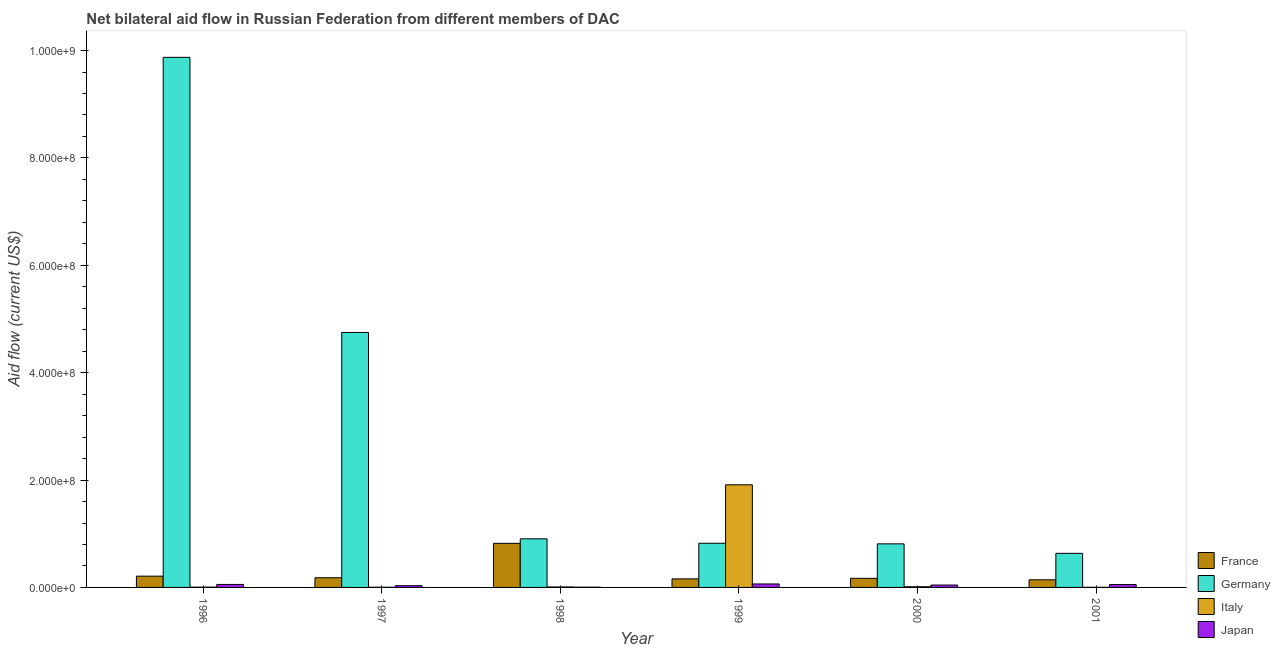Are the number of bars per tick equal to the number of legend labels?
Give a very brief answer. Yes. How many bars are there on the 3rd tick from the left?
Keep it short and to the point. 4. How many bars are there on the 3rd tick from the right?
Your answer should be very brief. 4. What is the amount of aid given by germany in 2000?
Offer a very short reply. 8.12e+07. Across all years, what is the maximum amount of aid given by italy?
Make the answer very short. 1.91e+08. Across all years, what is the minimum amount of aid given by italy?
Keep it short and to the point. 2.40e+05. In which year was the amount of aid given by france minimum?
Ensure brevity in your answer.  2001. What is the total amount of aid given by japan in the graph?
Give a very brief answer. 2.56e+07. What is the difference between the amount of aid given by france in 1997 and that in 1998?
Give a very brief answer. -6.41e+07. What is the difference between the amount of aid given by france in 2001 and the amount of aid given by japan in 1999?
Offer a terse response. -1.71e+06. What is the average amount of aid given by italy per year?
Offer a very short reply. 3.24e+07. What is the ratio of the amount of aid given by italy in 1998 to that in 2000?
Keep it short and to the point. 0.69. Is the amount of aid given by japan in 1996 less than that in 2001?
Offer a very short reply. No. What is the difference between the highest and the second highest amount of aid given by italy?
Your response must be concise. 1.90e+08. What is the difference between the highest and the lowest amount of aid given by france?
Offer a very short reply. 6.79e+07. What does the 1st bar from the left in 2000 represents?
Make the answer very short. France. What does the 3rd bar from the right in 2000 represents?
Your answer should be compact. Germany. Is it the case that in every year, the sum of the amount of aid given by france and amount of aid given by germany is greater than the amount of aid given by italy?
Provide a succinct answer. No. Does the graph contain any zero values?
Your response must be concise. No. Does the graph contain grids?
Keep it short and to the point. No. How many legend labels are there?
Your answer should be very brief. 4. How are the legend labels stacked?
Provide a short and direct response. Vertical. What is the title of the graph?
Make the answer very short. Net bilateral aid flow in Russian Federation from different members of DAC. What is the label or title of the X-axis?
Provide a short and direct response. Year. What is the label or title of the Y-axis?
Keep it short and to the point. Aid flow (current US$). What is the Aid flow (current US$) of France in 1996?
Your response must be concise. 2.10e+07. What is the Aid flow (current US$) in Germany in 1996?
Offer a very short reply. 9.87e+08. What is the Aid flow (current US$) of Italy in 1996?
Your answer should be compact. 5.10e+05. What is the Aid flow (current US$) in Japan in 1996?
Provide a succinct answer. 5.56e+06. What is the Aid flow (current US$) of France in 1997?
Give a very brief answer. 1.80e+07. What is the Aid flow (current US$) of Germany in 1997?
Provide a short and direct response. 4.75e+08. What is the Aid flow (current US$) in Italy in 1997?
Your answer should be compact. 3.00e+05. What is the Aid flow (current US$) in Japan in 1997?
Offer a very short reply. 3.26e+06. What is the Aid flow (current US$) in France in 1998?
Your answer should be very brief. 8.21e+07. What is the Aid flow (current US$) in Germany in 1998?
Offer a very short reply. 9.05e+07. What is the Aid flow (current US$) in Italy in 1998?
Keep it short and to the point. 8.80e+05. What is the Aid flow (current US$) in France in 1999?
Give a very brief answer. 1.59e+07. What is the Aid flow (current US$) in Germany in 1999?
Your response must be concise. 8.23e+07. What is the Aid flow (current US$) in Italy in 1999?
Your answer should be compact. 1.91e+08. What is the Aid flow (current US$) of Japan in 1999?
Give a very brief answer. 6.47e+06. What is the Aid flow (current US$) of France in 2000?
Your answer should be compact. 1.70e+07. What is the Aid flow (current US$) in Germany in 2000?
Ensure brevity in your answer.  8.12e+07. What is the Aid flow (current US$) in Italy in 2000?
Offer a very short reply. 1.28e+06. What is the Aid flow (current US$) of Japan in 2000?
Make the answer very short. 4.46e+06. What is the Aid flow (current US$) in France in 2001?
Ensure brevity in your answer.  1.42e+07. What is the Aid flow (current US$) of Germany in 2001?
Give a very brief answer. 6.35e+07. What is the Aid flow (current US$) in Japan in 2001?
Your answer should be compact. 5.31e+06. Across all years, what is the maximum Aid flow (current US$) of France?
Make the answer very short. 8.21e+07. Across all years, what is the maximum Aid flow (current US$) in Germany?
Make the answer very short. 9.87e+08. Across all years, what is the maximum Aid flow (current US$) in Italy?
Provide a succinct answer. 1.91e+08. Across all years, what is the maximum Aid flow (current US$) of Japan?
Your answer should be compact. 6.47e+06. Across all years, what is the minimum Aid flow (current US$) of France?
Provide a succinct answer. 1.42e+07. Across all years, what is the minimum Aid flow (current US$) in Germany?
Your answer should be very brief. 6.35e+07. What is the total Aid flow (current US$) in France in the graph?
Ensure brevity in your answer.  1.68e+08. What is the total Aid flow (current US$) in Germany in the graph?
Your response must be concise. 1.78e+09. What is the total Aid flow (current US$) in Italy in the graph?
Offer a terse response. 1.94e+08. What is the total Aid flow (current US$) in Japan in the graph?
Your answer should be very brief. 2.56e+07. What is the difference between the Aid flow (current US$) of France in 1996 and that in 1997?
Ensure brevity in your answer.  2.98e+06. What is the difference between the Aid flow (current US$) of Germany in 1996 and that in 1997?
Offer a very short reply. 5.12e+08. What is the difference between the Aid flow (current US$) in Italy in 1996 and that in 1997?
Your answer should be very brief. 2.10e+05. What is the difference between the Aid flow (current US$) in Japan in 1996 and that in 1997?
Offer a very short reply. 2.30e+06. What is the difference between the Aid flow (current US$) in France in 1996 and that in 1998?
Your answer should be compact. -6.11e+07. What is the difference between the Aid flow (current US$) of Germany in 1996 and that in 1998?
Your answer should be very brief. 8.97e+08. What is the difference between the Aid flow (current US$) in Italy in 1996 and that in 1998?
Give a very brief answer. -3.70e+05. What is the difference between the Aid flow (current US$) of Japan in 1996 and that in 1998?
Your answer should be very brief. 5.06e+06. What is the difference between the Aid flow (current US$) of France in 1996 and that in 1999?
Your response must be concise. 5.09e+06. What is the difference between the Aid flow (current US$) in Germany in 1996 and that in 1999?
Ensure brevity in your answer.  9.05e+08. What is the difference between the Aid flow (current US$) of Italy in 1996 and that in 1999?
Provide a succinct answer. -1.91e+08. What is the difference between the Aid flow (current US$) of Japan in 1996 and that in 1999?
Make the answer very short. -9.10e+05. What is the difference between the Aid flow (current US$) in France in 1996 and that in 2000?
Make the answer very short. 4.05e+06. What is the difference between the Aid flow (current US$) in Germany in 1996 and that in 2000?
Make the answer very short. 9.06e+08. What is the difference between the Aid flow (current US$) in Italy in 1996 and that in 2000?
Offer a very short reply. -7.70e+05. What is the difference between the Aid flow (current US$) of Japan in 1996 and that in 2000?
Provide a succinct answer. 1.10e+06. What is the difference between the Aid flow (current US$) in France in 1996 and that in 2001?
Give a very brief answer. 6.80e+06. What is the difference between the Aid flow (current US$) in Germany in 1996 and that in 2001?
Your answer should be compact. 9.24e+08. What is the difference between the Aid flow (current US$) of France in 1997 and that in 1998?
Give a very brief answer. -6.41e+07. What is the difference between the Aid flow (current US$) in Germany in 1997 and that in 1998?
Ensure brevity in your answer.  3.84e+08. What is the difference between the Aid flow (current US$) of Italy in 1997 and that in 1998?
Your answer should be compact. -5.80e+05. What is the difference between the Aid flow (current US$) of Japan in 1997 and that in 1998?
Offer a very short reply. 2.76e+06. What is the difference between the Aid flow (current US$) in France in 1997 and that in 1999?
Provide a short and direct response. 2.11e+06. What is the difference between the Aid flow (current US$) of Germany in 1997 and that in 1999?
Provide a short and direct response. 3.93e+08. What is the difference between the Aid flow (current US$) of Italy in 1997 and that in 1999?
Keep it short and to the point. -1.91e+08. What is the difference between the Aid flow (current US$) in Japan in 1997 and that in 1999?
Keep it short and to the point. -3.21e+06. What is the difference between the Aid flow (current US$) of France in 1997 and that in 2000?
Provide a short and direct response. 1.07e+06. What is the difference between the Aid flow (current US$) in Germany in 1997 and that in 2000?
Your answer should be very brief. 3.94e+08. What is the difference between the Aid flow (current US$) of Italy in 1997 and that in 2000?
Your response must be concise. -9.80e+05. What is the difference between the Aid flow (current US$) in Japan in 1997 and that in 2000?
Offer a very short reply. -1.20e+06. What is the difference between the Aid flow (current US$) of France in 1997 and that in 2001?
Provide a succinct answer. 3.82e+06. What is the difference between the Aid flow (current US$) of Germany in 1997 and that in 2001?
Your response must be concise. 4.11e+08. What is the difference between the Aid flow (current US$) in Japan in 1997 and that in 2001?
Provide a short and direct response. -2.05e+06. What is the difference between the Aid flow (current US$) of France in 1998 and that in 1999?
Offer a very short reply. 6.62e+07. What is the difference between the Aid flow (current US$) of Germany in 1998 and that in 1999?
Ensure brevity in your answer.  8.28e+06. What is the difference between the Aid flow (current US$) in Italy in 1998 and that in 1999?
Ensure brevity in your answer.  -1.90e+08. What is the difference between the Aid flow (current US$) of Japan in 1998 and that in 1999?
Offer a terse response. -5.97e+06. What is the difference between the Aid flow (current US$) of France in 1998 and that in 2000?
Offer a very short reply. 6.52e+07. What is the difference between the Aid flow (current US$) in Germany in 1998 and that in 2000?
Your answer should be compact. 9.39e+06. What is the difference between the Aid flow (current US$) in Italy in 1998 and that in 2000?
Keep it short and to the point. -4.00e+05. What is the difference between the Aid flow (current US$) in Japan in 1998 and that in 2000?
Your answer should be very brief. -3.96e+06. What is the difference between the Aid flow (current US$) in France in 1998 and that in 2001?
Keep it short and to the point. 6.79e+07. What is the difference between the Aid flow (current US$) in Germany in 1998 and that in 2001?
Offer a terse response. 2.70e+07. What is the difference between the Aid flow (current US$) in Italy in 1998 and that in 2001?
Give a very brief answer. 6.40e+05. What is the difference between the Aid flow (current US$) in Japan in 1998 and that in 2001?
Keep it short and to the point. -4.81e+06. What is the difference between the Aid flow (current US$) of France in 1999 and that in 2000?
Keep it short and to the point. -1.04e+06. What is the difference between the Aid flow (current US$) of Germany in 1999 and that in 2000?
Keep it short and to the point. 1.11e+06. What is the difference between the Aid flow (current US$) of Italy in 1999 and that in 2000?
Offer a very short reply. 1.90e+08. What is the difference between the Aid flow (current US$) of Japan in 1999 and that in 2000?
Provide a succinct answer. 2.01e+06. What is the difference between the Aid flow (current US$) of France in 1999 and that in 2001?
Offer a terse response. 1.71e+06. What is the difference between the Aid flow (current US$) in Germany in 1999 and that in 2001?
Give a very brief answer. 1.88e+07. What is the difference between the Aid flow (current US$) of Italy in 1999 and that in 2001?
Provide a succinct answer. 1.91e+08. What is the difference between the Aid flow (current US$) in Japan in 1999 and that in 2001?
Provide a short and direct response. 1.16e+06. What is the difference between the Aid flow (current US$) of France in 2000 and that in 2001?
Your response must be concise. 2.75e+06. What is the difference between the Aid flow (current US$) in Germany in 2000 and that in 2001?
Make the answer very short. 1.76e+07. What is the difference between the Aid flow (current US$) of Italy in 2000 and that in 2001?
Offer a very short reply. 1.04e+06. What is the difference between the Aid flow (current US$) in Japan in 2000 and that in 2001?
Provide a short and direct response. -8.50e+05. What is the difference between the Aid flow (current US$) in France in 1996 and the Aid flow (current US$) in Germany in 1997?
Provide a short and direct response. -4.54e+08. What is the difference between the Aid flow (current US$) in France in 1996 and the Aid flow (current US$) in Italy in 1997?
Make the answer very short. 2.07e+07. What is the difference between the Aid flow (current US$) in France in 1996 and the Aid flow (current US$) in Japan in 1997?
Provide a short and direct response. 1.77e+07. What is the difference between the Aid flow (current US$) of Germany in 1996 and the Aid flow (current US$) of Italy in 1997?
Your response must be concise. 9.87e+08. What is the difference between the Aid flow (current US$) of Germany in 1996 and the Aid flow (current US$) of Japan in 1997?
Your answer should be compact. 9.84e+08. What is the difference between the Aid flow (current US$) in Italy in 1996 and the Aid flow (current US$) in Japan in 1997?
Give a very brief answer. -2.75e+06. What is the difference between the Aid flow (current US$) of France in 1996 and the Aid flow (current US$) of Germany in 1998?
Your response must be concise. -6.95e+07. What is the difference between the Aid flow (current US$) of France in 1996 and the Aid flow (current US$) of Italy in 1998?
Provide a succinct answer. 2.01e+07. What is the difference between the Aid flow (current US$) of France in 1996 and the Aid flow (current US$) of Japan in 1998?
Provide a succinct answer. 2.05e+07. What is the difference between the Aid flow (current US$) of Germany in 1996 and the Aid flow (current US$) of Italy in 1998?
Ensure brevity in your answer.  9.86e+08. What is the difference between the Aid flow (current US$) of Germany in 1996 and the Aid flow (current US$) of Japan in 1998?
Make the answer very short. 9.87e+08. What is the difference between the Aid flow (current US$) of France in 1996 and the Aid flow (current US$) of Germany in 1999?
Keep it short and to the point. -6.13e+07. What is the difference between the Aid flow (current US$) in France in 1996 and the Aid flow (current US$) in Italy in 1999?
Keep it short and to the point. -1.70e+08. What is the difference between the Aid flow (current US$) in France in 1996 and the Aid flow (current US$) in Japan in 1999?
Make the answer very short. 1.45e+07. What is the difference between the Aid flow (current US$) in Germany in 1996 and the Aid flow (current US$) in Italy in 1999?
Your response must be concise. 7.96e+08. What is the difference between the Aid flow (current US$) in Germany in 1996 and the Aid flow (current US$) in Japan in 1999?
Offer a very short reply. 9.81e+08. What is the difference between the Aid flow (current US$) in Italy in 1996 and the Aid flow (current US$) in Japan in 1999?
Your answer should be very brief. -5.96e+06. What is the difference between the Aid flow (current US$) of France in 1996 and the Aid flow (current US$) of Germany in 2000?
Provide a succinct answer. -6.02e+07. What is the difference between the Aid flow (current US$) in France in 1996 and the Aid flow (current US$) in Italy in 2000?
Your response must be concise. 1.97e+07. What is the difference between the Aid flow (current US$) in France in 1996 and the Aid flow (current US$) in Japan in 2000?
Your answer should be very brief. 1.65e+07. What is the difference between the Aid flow (current US$) in Germany in 1996 and the Aid flow (current US$) in Italy in 2000?
Offer a very short reply. 9.86e+08. What is the difference between the Aid flow (current US$) in Germany in 1996 and the Aid flow (current US$) in Japan in 2000?
Provide a short and direct response. 9.83e+08. What is the difference between the Aid flow (current US$) in Italy in 1996 and the Aid flow (current US$) in Japan in 2000?
Provide a short and direct response. -3.95e+06. What is the difference between the Aid flow (current US$) of France in 1996 and the Aid flow (current US$) of Germany in 2001?
Your answer should be very brief. -4.25e+07. What is the difference between the Aid flow (current US$) in France in 1996 and the Aid flow (current US$) in Italy in 2001?
Your answer should be very brief. 2.08e+07. What is the difference between the Aid flow (current US$) of France in 1996 and the Aid flow (current US$) of Japan in 2001?
Provide a succinct answer. 1.57e+07. What is the difference between the Aid flow (current US$) of Germany in 1996 and the Aid flow (current US$) of Italy in 2001?
Your answer should be very brief. 9.87e+08. What is the difference between the Aid flow (current US$) of Germany in 1996 and the Aid flow (current US$) of Japan in 2001?
Provide a short and direct response. 9.82e+08. What is the difference between the Aid flow (current US$) in Italy in 1996 and the Aid flow (current US$) in Japan in 2001?
Your answer should be compact. -4.80e+06. What is the difference between the Aid flow (current US$) of France in 1997 and the Aid flow (current US$) of Germany in 1998?
Offer a very short reply. -7.25e+07. What is the difference between the Aid flow (current US$) of France in 1997 and the Aid flow (current US$) of Italy in 1998?
Your answer should be very brief. 1.71e+07. What is the difference between the Aid flow (current US$) of France in 1997 and the Aid flow (current US$) of Japan in 1998?
Provide a succinct answer. 1.75e+07. What is the difference between the Aid flow (current US$) of Germany in 1997 and the Aid flow (current US$) of Italy in 1998?
Your answer should be very brief. 4.74e+08. What is the difference between the Aid flow (current US$) of Germany in 1997 and the Aid flow (current US$) of Japan in 1998?
Your answer should be very brief. 4.74e+08. What is the difference between the Aid flow (current US$) of France in 1997 and the Aid flow (current US$) of Germany in 1999?
Provide a short and direct response. -6.42e+07. What is the difference between the Aid flow (current US$) in France in 1997 and the Aid flow (current US$) in Italy in 1999?
Make the answer very short. -1.73e+08. What is the difference between the Aid flow (current US$) of France in 1997 and the Aid flow (current US$) of Japan in 1999?
Offer a very short reply. 1.16e+07. What is the difference between the Aid flow (current US$) of Germany in 1997 and the Aid flow (current US$) of Italy in 1999?
Offer a very short reply. 2.84e+08. What is the difference between the Aid flow (current US$) of Germany in 1997 and the Aid flow (current US$) of Japan in 1999?
Your answer should be very brief. 4.68e+08. What is the difference between the Aid flow (current US$) of Italy in 1997 and the Aid flow (current US$) of Japan in 1999?
Ensure brevity in your answer.  -6.17e+06. What is the difference between the Aid flow (current US$) of France in 1997 and the Aid flow (current US$) of Germany in 2000?
Make the answer very short. -6.31e+07. What is the difference between the Aid flow (current US$) of France in 1997 and the Aid flow (current US$) of Italy in 2000?
Offer a very short reply. 1.67e+07. What is the difference between the Aid flow (current US$) in France in 1997 and the Aid flow (current US$) in Japan in 2000?
Your response must be concise. 1.36e+07. What is the difference between the Aid flow (current US$) of Germany in 1997 and the Aid flow (current US$) of Italy in 2000?
Offer a terse response. 4.74e+08. What is the difference between the Aid flow (current US$) in Germany in 1997 and the Aid flow (current US$) in Japan in 2000?
Give a very brief answer. 4.70e+08. What is the difference between the Aid flow (current US$) of Italy in 1997 and the Aid flow (current US$) of Japan in 2000?
Offer a terse response. -4.16e+06. What is the difference between the Aid flow (current US$) of France in 1997 and the Aid flow (current US$) of Germany in 2001?
Give a very brief answer. -4.55e+07. What is the difference between the Aid flow (current US$) of France in 1997 and the Aid flow (current US$) of Italy in 2001?
Make the answer very short. 1.78e+07. What is the difference between the Aid flow (current US$) of France in 1997 and the Aid flow (current US$) of Japan in 2001?
Your response must be concise. 1.27e+07. What is the difference between the Aid flow (current US$) in Germany in 1997 and the Aid flow (current US$) in Italy in 2001?
Provide a short and direct response. 4.75e+08. What is the difference between the Aid flow (current US$) of Germany in 1997 and the Aid flow (current US$) of Japan in 2001?
Offer a terse response. 4.70e+08. What is the difference between the Aid flow (current US$) of Italy in 1997 and the Aid flow (current US$) of Japan in 2001?
Your response must be concise. -5.01e+06. What is the difference between the Aid flow (current US$) in France in 1998 and the Aid flow (current US$) in Germany in 1999?
Your answer should be very brief. -1.30e+05. What is the difference between the Aid flow (current US$) in France in 1998 and the Aid flow (current US$) in Italy in 1999?
Offer a terse response. -1.09e+08. What is the difference between the Aid flow (current US$) in France in 1998 and the Aid flow (current US$) in Japan in 1999?
Provide a short and direct response. 7.57e+07. What is the difference between the Aid flow (current US$) in Germany in 1998 and the Aid flow (current US$) in Italy in 1999?
Ensure brevity in your answer.  -1.01e+08. What is the difference between the Aid flow (current US$) of Germany in 1998 and the Aid flow (current US$) of Japan in 1999?
Ensure brevity in your answer.  8.41e+07. What is the difference between the Aid flow (current US$) of Italy in 1998 and the Aid flow (current US$) of Japan in 1999?
Provide a short and direct response. -5.59e+06. What is the difference between the Aid flow (current US$) in France in 1998 and the Aid flow (current US$) in Germany in 2000?
Make the answer very short. 9.80e+05. What is the difference between the Aid flow (current US$) in France in 1998 and the Aid flow (current US$) in Italy in 2000?
Give a very brief answer. 8.08e+07. What is the difference between the Aid flow (current US$) of France in 1998 and the Aid flow (current US$) of Japan in 2000?
Keep it short and to the point. 7.77e+07. What is the difference between the Aid flow (current US$) of Germany in 1998 and the Aid flow (current US$) of Italy in 2000?
Ensure brevity in your answer.  8.93e+07. What is the difference between the Aid flow (current US$) of Germany in 1998 and the Aid flow (current US$) of Japan in 2000?
Your response must be concise. 8.61e+07. What is the difference between the Aid flow (current US$) of Italy in 1998 and the Aid flow (current US$) of Japan in 2000?
Make the answer very short. -3.58e+06. What is the difference between the Aid flow (current US$) of France in 1998 and the Aid flow (current US$) of Germany in 2001?
Your answer should be compact. 1.86e+07. What is the difference between the Aid flow (current US$) of France in 1998 and the Aid flow (current US$) of Italy in 2001?
Provide a short and direct response. 8.19e+07. What is the difference between the Aid flow (current US$) of France in 1998 and the Aid flow (current US$) of Japan in 2001?
Give a very brief answer. 7.68e+07. What is the difference between the Aid flow (current US$) in Germany in 1998 and the Aid flow (current US$) in Italy in 2001?
Your answer should be very brief. 9.03e+07. What is the difference between the Aid flow (current US$) in Germany in 1998 and the Aid flow (current US$) in Japan in 2001?
Give a very brief answer. 8.52e+07. What is the difference between the Aid flow (current US$) of Italy in 1998 and the Aid flow (current US$) of Japan in 2001?
Provide a short and direct response. -4.43e+06. What is the difference between the Aid flow (current US$) of France in 1999 and the Aid flow (current US$) of Germany in 2000?
Your answer should be very brief. -6.52e+07. What is the difference between the Aid flow (current US$) of France in 1999 and the Aid flow (current US$) of Italy in 2000?
Keep it short and to the point. 1.46e+07. What is the difference between the Aid flow (current US$) in France in 1999 and the Aid flow (current US$) in Japan in 2000?
Your response must be concise. 1.14e+07. What is the difference between the Aid flow (current US$) in Germany in 1999 and the Aid flow (current US$) in Italy in 2000?
Keep it short and to the point. 8.10e+07. What is the difference between the Aid flow (current US$) in Germany in 1999 and the Aid flow (current US$) in Japan in 2000?
Provide a succinct answer. 7.78e+07. What is the difference between the Aid flow (current US$) in Italy in 1999 and the Aid flow (current US$) in Japan in 2000?
Your answer should be compact. 1.87e+08. What is the difference between the Aid flow (current US$) in France in 1999 and the Aid flow (current US$) in Germany in 2001?
Your response must be concise. -4.76e+07. What is the difference between the Aid flow (current US$) of France in 1999 and the Aid flow (current US$) of Italy in 2001?
Keep it short and to the point. 1.57e+07. What is the difference between the Aid flow (current US$) of France in 1999 and the Aid flow (current US$) of Japan in 2001?
Your response must be concise. 1.06e+07. What is the difference between the Aid flow (current US$) of Germany in 1999 and the Aid flow (current US$) of Italy in 2001?
Give a very brief answer. 8.20e+07. What is the difference between the Aid flow (current US$) in Germany in 1999 and the Aid flow (current US$) in Japan in 2001?
Provide a short and direct response. 7.70e+07. What is the difference between the Aid flow (current US$) in Italy in 1999 and the Aid flow (current US$) in Japan in 2001?
Make the answer very short. 1.86e+08. What is the difference between the Aid flow (current US$) of France in 2000 and the Aid flow (current US$) of Germany in 2001?
Your answer should be compact. -4.66e+07. What is the difference between the Aid flow (current US$) in France in 2000 and the Aid flow (current US$) in Italy in 2001?
Give a very brief answer. 1.67e+07. What is the difference between the Aid flow (current US$) in France in 2000 and the Aid flow (current US$) in Japan in 2001?
Your answer should be very brief. 1.16e+07. What is the difference between the Aid flow (current US$) in Germany in 2000 and the Aid flow (current US$) in Italy in 2001?
Make the answer very short. 8.09e+07. What is the difference between the Aid flow (current US$) in Germany in 2000 and the Aid flow (current US$) in Japan in 2001?
Offer a terse response. 7.58e+07. What is the difference between the Aid flow (current US$) of Italy in 2000 and the Aid flow (current US$) of Japan in 2001?
Your answer should be compact. -4.03e+06. What is the average Aid flow (current US$) of France per year?
Provide a short and direct response. 2.80e+07. What is the average Aid flow (current US$) in Germany per year?
Offer a very short reply. 2.97e+08. What is the average Aid flow (current US$) of Italy per year?
Your response must be concise. 3.24e+07. What is the average Aid flow (current US$) of Japan per year?
Your answer should be compact. 4.26e+06. In the year 1996, what is the difference between the Aid flow (current US$) of France and Aid flow (current US$) of Germany?
Offer a terse response. -9.66e+08. In the year 1996, what is the difference between the Aid flow (current US$) of France and Aid flow (current US$) of Italy?
Ensure brevity in your answer.  2.05e+07. In the year 1996, what is the difference between the Aid flow (current US$) of France and Aid flow (current US$) of Japan?
Offer a terse response. 1.54e+07. In the year 1996, what is the difference between the Aid flow (current US$) of Germany and Aid flow (current US$) of Italy?
Provide a succinct answer. 9.87e+08. In the year 1996, what is the difference between the Aid flow (current US$) in Germany and Aid flow (current US$) in Japan?
Your answer should be compact. 9.82e+08. In the year 1996, what is the difference between the Aid flow (current US$) in Italy and Aid flow (current US$) in Japan?
Offer a very short reply. -5.05e+06. In the year 1997, what is the difference between the Aid flow (current US$) of France and Aid flow (current US$) of Germany?
Offer a very short reply. -4.57e+08. In the year 1997, what is the difference between the Aid flow (current US$) of France and Aid flow (current US$) of Italy?
Provide a succinct answer. 1.77e+07. In the year 1997, what is the difference between the Aid flow (current US$) in France and Aid flow (current US$) in Japan?
Ensure brevity in your answer.  1.48e+07. In the year 1997, what is the difference between the Aid flow (current US$) of Germany and Aid flow (current US$) of Italy?
Provide a short and direct response. 4.75e+08. In the year 1997, what is the difference between the Aid flow (current US$) in Germany and Aid flow (current US$) in Japan?
Your answer should be very brief. 4.72e+08. In the year 1997, what is the difference between the Aid flow (current US$) of Italy and Aid flow (current US$) of Japan?
Your answer should be compact. -2.96e+06. In the year 1998, what is the difference between the Aid flow (current US$) in France and Aid flow (current US$) in Germany?
Offer a terse response. -8.41e+06. In the year 1998, what is the difference between the Aid flow (current US$) of France and Aid flow (current US$) of Italy?
Give a very brief answer. 8.12e+07. In the year 1998, what is the difference between the Aid flow (current US$) of France and Aid flow (current US$) of Japan?
Make the answer very short. 8.16e+07. In the year 1998, what is the difference between the Aid flow (current US$) in Germany and Aid flow (current US$) in Italy?
Your response must be concise. 8.97e+07. In the year 1998, what is the difference between the Aid flow (current US$) in Germany and Aid flow (current US$) in Japan?
Offer a terse response. 9.00e+07. In the year 1998, what is the difference between the Aid flow (current US$) of Italy and Aid flow (current US$) of Japan?
Make the answer very short. 3.80e+05. In the year 1999, what is the difference between the Aid flow (current US$) in France and Aid flow (current US$) in Germany?
Provide a short and direct response. -6.64e+07. In the year 1999, what is the difference between the Aid flow (current US$) of France and Aid flow (current US$) of Italy?
Provide a succinct answer. -1.75e+08. In the year 1999, what is the difference between the Aid flow (current US$) in France and Aid flow (current US$) in Japan?
Offer a very short reply. 9.44e+06. In the year 1999, what is the difference between the Aid flow (current US$) in Germany and Aid flow (current US$) in Italy?
Ensure brevity in your answer.  -1.09e+08. In the year 1999, what is the difference between the Aid flow (current US$) of Germany and Aid flow (current US$) of Japan?
Keep it short and to the point. 7.58e+07. In the year 1999, what is the difference between the Aid flow (current US$) of Italy and Aid flow (current US$) of Japan?
Ensure brevity in your answer.  1.85e+08. In the year 2000, what is the difference between the Aid flow (current US$) of France and Aid flow (current US$) of Germany?
Provide a short and direct response. -6.42e+07. In the year 2000, what is the difference between the Aid flow (current US$) in France and Aid flow (current US$) in Italy?
Ensure brevity in your answer.  1.57e+07. In the year 2000, what is the difference between the Aid flow (current US$) of France and Aid flow (current US$) of Japan?
Offer a terse response. 1.25e+07. In the year 2000, what is the difference between the Aid flow (current US$) in Germany and Aid flow (current US$) in Italy?
Provide a succinct answer. 7.99e+07. In the year 2000, what is the difference between the Aid flow (current US$) in Germany and Aid flow (current US$) in Japan?
Provide a succinct answer. 7.67e+07. In the year 2000, what is the difference between the Aid flow (current US$) in Italy and Aid flow (current US$) in Japan?
Your response must be concise. -3.18e+06. In the year 2001, what is the difference between the Aid flow (current US$) in France and Aid flow (current US$) in Germany?
Make the answer very short. -4.93e+07. In the year 2001, what is the difference between the Aid flow (current US$) in France and Aid flow (current US$) in Italy?
Make the answer very short. 1.40e+07. In the year 2001, what is the difference between the Aid flow (current US$) of France and Aid flow (current US$) of Japan?
Your answer should be very brief. 8.89e+06. In the year 2001, what is the difference between the Aid flow (current US$) of Germany and Aid flow (current US$) of Italy?
Your answer should be very brief. 6.33e+07. In the year 2001, what is the difference between the Aid flow (current US$) of Germany and Aid flow (current US$) of Japan?
Provide a succinct answer. 5.82e+07. In the year 2001, what is the difference between the Aid flow (current US$) in Italy and Aid flow (current US$) in Japan?
Your response must be concise. -5.07e+06. What is the ratio of the Aid flow (current US$) in France in 1996 to that in 1997?
Give a very brief answer. 1.17. What is the ratio of the Aid flow (current US$) in Germany in 1996 to that in 1997?
Make the answer very short. 2.08. What is the ratio of the Aid flow (current US$) in Italy in 1996 to that in 1997?
Provide a short and direct response. 1.7. What is the ratio of the Aid flow (current US$) in Japan in 1996 to that in 1997?
Ensure brevity in your answer.  1.71. What is the ratio of the Aid flow (current US$) in France in 1996 to that in 1998?
Keep it short and to the point. 0.26. What is the ratio of the Aid flow (current US$) of Germany in 1996 to that in 1998?
Your answer should be compact. 10.91. What is the ratio of the Aid flow (current US$) of Italy in 1996 to that in 1998?
Offer a very short reply. 0.58. What is the ratio of the Aid flow (current US$) in Japan in 1996 to that in 1998?
Make the answer very short. 11.12. What is the ratio of the Aid flow (current US$) in France in 1996 to that in 1999?
Provide a short and direct response. 1.32. What is the ratio of the Aid flow (current US$) in Germany in 1996 to that in 1999?
Give a very brief answer. 12. What is the ratio of the Aid flow (current US$) of Italy in 1996 to that in 1999?
Ensure brevity in your answer.  0. What is the ratio of the Aid flow (current US$) of Japan in 1996 to that in 1999?
Keep it short and to the point. 0.86. What is the ratio of the Aid flow (current US$) in France in 1996 to that in 2000?
Your answer should be compact. 1.24. What is the ratio of the Aid flow (current US$) of Germany in 1996 to that in 2000?
Provide a short and direct response. 12.17. What is the ratio of the Aid flow (current US$) of Italy in 1996 to that in 2000?
Your response must be concise. 0.4. What is the ratio of the Aid flow (current US$) in Japan in 1996 to that in 2000?
Keep it short and to the point. 1.25. What is the ratio of the Aid flow (current US$) of France in 1996 to that in 2001?
Provide a succinct answer. 1.48. What is the ratio of the Aid flow (current US$) of Germany in 1996 to that in 2001?
Your response must be concise. 15.55. What is the ratio of the Aid flow (current US$) of Italy in 1996 to that in 2001?
Offer a terse response. 2.12. What is the ratio of the Aid flow (current US$) of Japan in 1996 to that in 2001?
Your response must be concise. 1.05. What is the ratio of the Aid flow (current US$) of France in 1997 to that in 1998?
Your answer should be compact. 0.22. What is the ratio of the Aid flow (current US$) of Germany in 1997 to that in 1998?
Your answer should be very brief. 5.25. What is the ratio of the Aid flow (current US$) of Italy in 1997 to that in 1998?
Your answer should be very brief. 0.34. What is the ratio of the Aid flow (current US$) in Japan in 1997 to that in 1998?
Keep it short and to the point. 6.52. What is the ratio of the Aid flow (current US$) of France in 1997 to that in 1999?
Offer a terse response. 1.13. What is the ratio of the Aid flow (current US$) of Germany in 1997 to that in 1999?
Offer a very short reply. 5.77. What is the ratio of the Aid flow (current US$) in Italy in 1997 to that in 1999?
Your response must be concise. 0. What is the ratio of the Aid flow (current US$) of Japan in 1997 to that in 1999?
Provide a succinct answer. 0.5. What is the ratio of the Aid flow (current US$) in France in 1997 to that in 2000?
Give a very brief answer. 1.06. What is the ratio of the Aid flow (current US$) in Germany in 1997 to that in 2000?
Give a very brief answer. 5.85. What is the ratio of the Aid flow (current US$) of Italy in 1997 to that in 2000?
Make the answer very short. 0.23. What is the ratio of the Aid flow (current US$) of Japan in 1997 to that in 2000?
Your response must be concise. 0.73. What is the ratio of the Aid flow (current US$) of France in 1997 to that in 2001?
Offer a very short reply. 1.27. What is the ratio of the Aid flow (current US$) of Germany in 1997 to that in 2001?
Your response must be concise. 7.48. What is the ratio of the Aid flow (current US$) of Italy in 1997 to that in 2001?
Provide a short and direct response. 1.25. What is the ratio of the Aid flow (current US$) in Japan in 1997 to that in 2001?
Your answer should be very brief. 0.61. What is the ratio of the Aid flow (current US$) in France in 1998 to that in 1999?
Ensure brevity in your answer.  5.16. What is the ratio of the Aid flow (current US$) of Germany in 1998 to that in 1999?
Offer a terse response. 1.1. What is the ratio of the Aid flow (current US$) of Italy in 1998 to that in 1999?
Your answer should be very brief. 0. What is the ratio of the Aid flow (current US$) of Japan in 1998 to that in 1999?
Provide a succinct answer. 0.08. What is the ratio of the Aid flow (current US$) of France in 1998 to that in 2000?
Your response must be concise. 4.85. What is the ratio of the Aid flow (current US$) in Germany in 1998 to that in 2000?
Your answer should be very brief. 1.12. What is the ratio of the Aid flow (current US$) in Italy in 1998 to that in 2000?
Keep it short and to the point. 0.69. What is the ratio of the Aid flow (current US$) in Japan in 1998 to that in 2000?
Keep it short and to the point. 0.11. What is the ratio of the Aid flow (current US$) in France in 1998 to that in 2001?
Your answer should be very brief. 5.78. What is the ratio of the Aid flow (current US$) of Germany in 1998 to that in 2001?
Provide a succinct answer. 1.43. What is the ratio of the Aid flow (current US$) in Italy in 1998 to that in 2001?
Ensure brevity in your answer.  3.67. What is the ratio of the Aid flow (current US$) of Japan in 1998 to that in 2001?
Your response must be concise. 0.09. What is the ratio of the Aid flow (current US$) in France in 1999 to that in 2000?
Keep it short and to the point. 0.94. What is the ratio of the Aid flow (current US$) of Germany in 1999 to that in 2000?
Your answer should be compact. 1.01. What is the ratio of the Aid flow (current US$) in Italy in 1999 to that in 2000?
Your answer should be compact. 149.34. What is the ratio of the Aid flow (current US$) of Japan in 1999 to that in 2000?
Offer a very short reply. 1.45. What is the ratio of the Aid flow (current US$) in France in 1999 to that in 2001?
Offer a terse response. 1.12. What is the ratio of the Aid flow (current US$) of Germany in 1999 to that in 2001?
Offer a very short reply. 1.3. What is the ratio of the Aid flow (current US$) of Italy in 1999 to that in 2001?
Provide a succinct answer. 796.46. What is the ratio of the Aid flow (current US$) in Japan in 1999 to that in 2001?
Your answer should be very brief. 1.22. What is the ratio of the Aid flow (current US$) of France in 2000 to that in 2001?
Ensure brevity in your answer.  1.19. What is the ratio of the Aid flow (current US$) of Germany in 2000 to that in 2001?
Keep it short and to the point. 1.28. What is the ratio of the Aid flow (current US$) of Italy in 2000 to that in 2001?
Offer a terse response. 5.33. What is the ratio of the Aid flow (current US$) of Japan in 2000 to that in 2001?
Provide a succinct answer. 0.84. What is the difference between the highest and the second highest Aid flow (current US$) in France?
Give a very brief answer. 6.11e+07. What is the difference between the highest and the second highest Aid flow (current US$) of Germany?
Offer a terse response. 5.12e+08. What is the difference between the highest and the second highest Aid flow (current US$) in Italy?
Make the answer very short. 1.90e+08. What is the difference between the highest and the second highest Aid flow (current US$) of Japan?
Give a very brief answer. 9.10e+05. What is the difference between the highest and the lowest Aid flow (current US$) in France?
Offer a very short reply. 6.79e+07. What is the difference between the highest and the lowest Aid flow (current US$) of Germany?
Make the answer very short. 9.24e+08. What is the difference between the highest and the lowest Aid flow (current US$) in Italy?
Keep it short and to the point. 1.91e+08. What is the difference between the highest and the lowest Aid flow (current US$) of Japan?
Make the answer very short. 5.97e+06. 